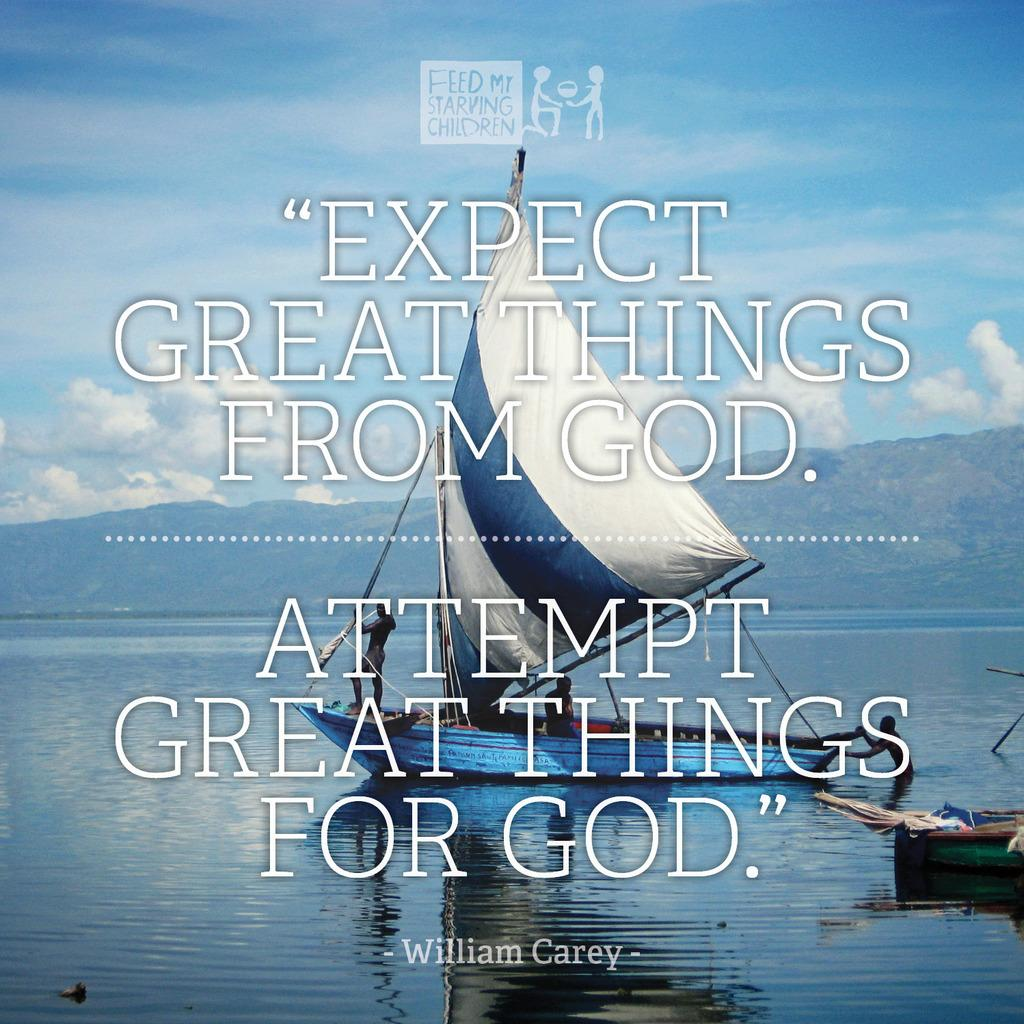<image>
Summarize the visual content of the image. A quote in front of a boat on the water to expect great things from God. 